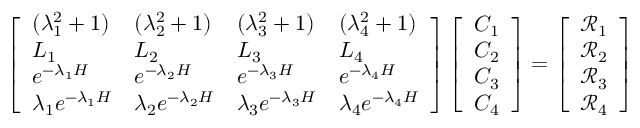<formula> <loc_0><loc_0><loc_500><loc_500>\left [ \begin{array} { l l l l } { ( \lambda _ { 1 } ^ { 2 } + 1 ) } & { ( \lambda _ { 2 } ^ { 2 } + 1 ) } & { ( \lambda _ { 3 } ^ { 2 } + 1 ) } & { ( \lambda _ { 4 } ^ { 2 } + 1 ) } \\ { L _ { 1 } } & { L _ { 2 } } & { L _ { 3 } } & { L _ { 4 } } \\ { e ^ { - \lambda _ { 1 } H } } & { e ^ { - \lambda _ { 2 } H } } & { e ^ { - \lambda _ { 3 } H } } & { e ^ { - \lambda _ { 4 } H } } \\ { \lambda _ { 1 } e ^ { - \lambda _ { 1 } H } } & { \lambda _ { 2 } e ^ { - \lambda _ { 2 } H } } & { \lambda _ { 3 } e ^ { - \lambda _ { 3 } H } } & { \lambda _ { 4 } e ^ { - \lambda _ { 4 } H } } \end{array} \right ] \left [ \begin{array} { l } { C _ { 1 } } \\ { C _ { 2 } } \\ { C _ { 3 } } \\ { C _ { 4 } } \end{array} \right ] = \left [ \begin{array} { l } { \ m a t h s c r { R } _ { 1 } } \\ { \ m a t h s c r { R } _ { 2 } } \\ { \ m a t h s c r { R } _ { 3 } } \\ { \ m a t h s c r { R } _ { 4 } } \end{array} \right ]</formula> 